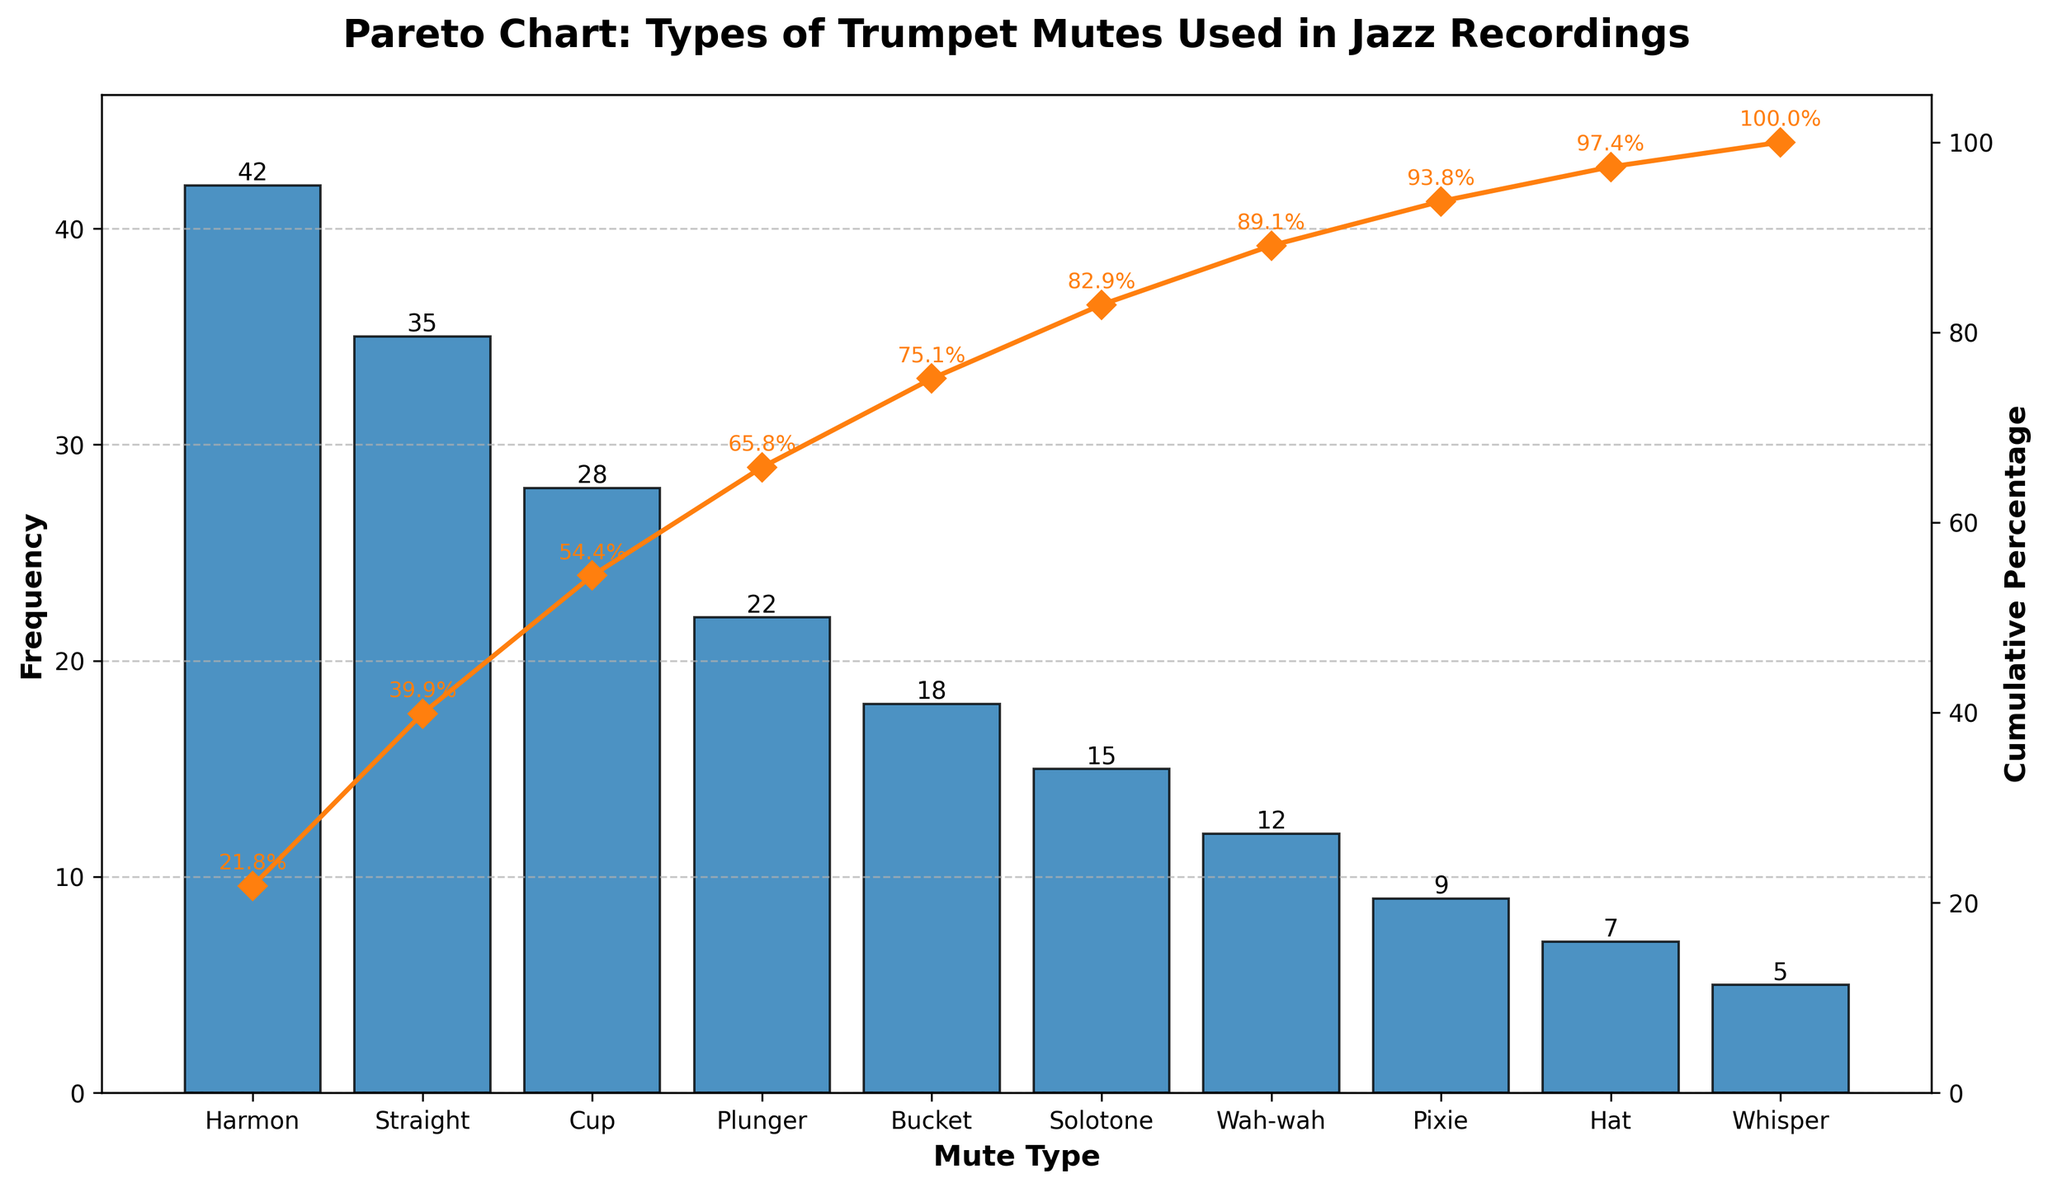what is the most popular mute type for jazz recordings? The most popular mute type is identified by the highest bar in the chart. The bar for "Harmon" is the highest with a frequency of 42.
Answer: Harmon which mute type has a frequency of 22? The x-axis labels of the chart show "Plunger" corresponds to a frequency of 22, as indicated by the bar height.
Answer: Plunger how many mute types have a frequency greater than 20? Inspect the bar heights. "Harmon," "Straight," "Cup," and "Plunger" have frequencies above 20. Count these bars.
Answer: 4 which mutes account for approximately 75% of the cumulative percentage? Consult the cumulative percentage line. The cumulative percentage reaches around 75% at the "Bucket" mute type. The mutes "Harmon," "Straight," "Cup," "Plunger," and "Bucket" collectively account for this.
Answer: Harmon, Straight, Cup, Plunger, Bucket which mute type has the lowest frequency and what is it? Look for the shortest bar in the chart. The "Whisper" mute has the lowest frequency with a value of 5 according to the bar height.
Answer: Whisper, 5 what is the cumulative percentage after 3 mute types? Follow the cumulative percentage line after the third mute type, "Cup." The cumulative percentage for the first three is 64.5%.
Answer: 64.5% what is the total frequency for the top 3 mutes? Add the frequencies of the top three mutes: Harmon (42), Straight (35), and Cup (28): 42 + 35 + 28 = 105.
Answer: 105 how much more popular is the Harmon mute compared to the Pixie mute in frequency? Subtract the frequency of Pixie (9) from Harmon (42): 42 - 9 = 33.
Answer: 33 which mutes have a cumulative percentage less than 35%? Follow the cumulative percentage line until it reaches 35%. The mutes "Harmon" and "Straight" collectively have a cumulative percentage less than 35%.
Answer: Harmon, Straight what percentage does the Solotone mute contribute to the cumulative percentage? Locate the cumulative percentage at the Solotone mute type on the line chart. It is identified at 79%. The percentage contribution to cumulative is then 79% - 67% (previous value): 12%.
Answer: 12% 